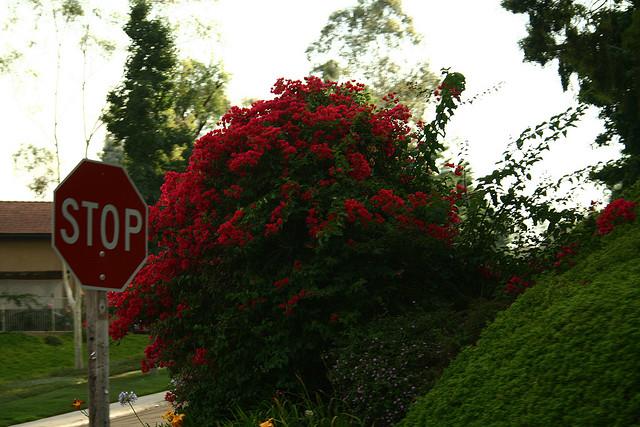What color are the flowers on the bush?
Write a very short answer. Red. What is fresh?
Write a very short answer. Flowers. What traffic control device is being used?
Short answer required. Stop sign. What is growing next to the sign?
Give a very brief answer. Flowers. 